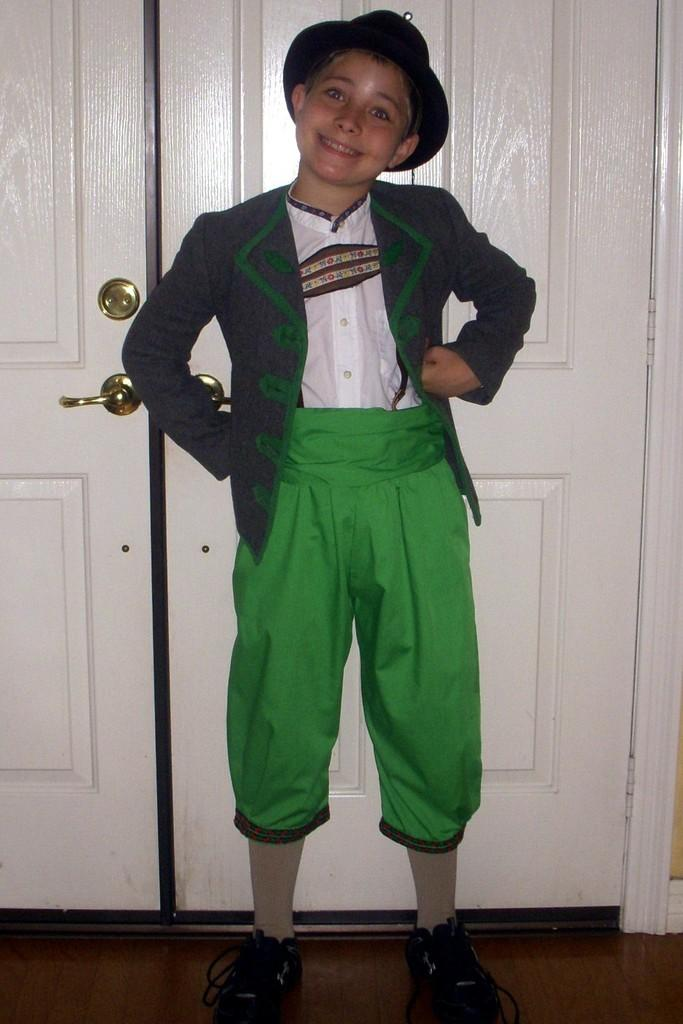Who is present in the image? There is a boy in the image. What is the boy wearing on his head? The boy is wearing a hat. What is the boy's facial expression in the image? The boy is smiling. What surface is the boy standing on? The boy is standing on the floor. What can be seen in the background of the image? There are white doors in the background of the image. What type of rifle is the boy holding in the image? There is no rifle present in the image; the boy is only wearing a hat and smiling. 